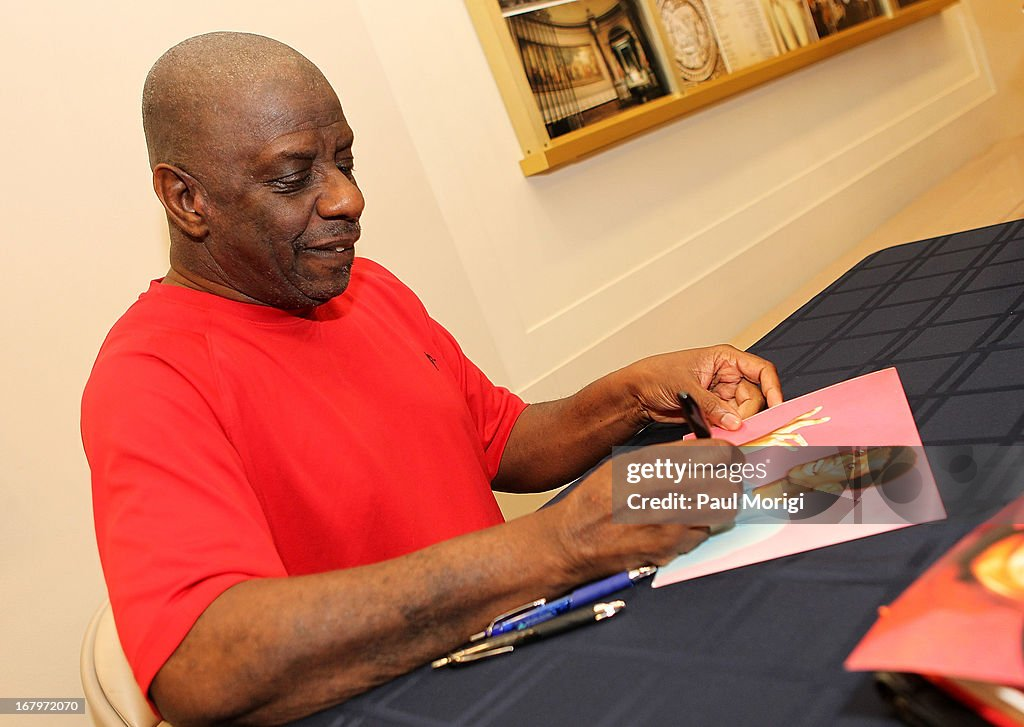Can you describe the location settings and how they contribute to the event atmosphere? The location appears to be a well-lit, indoor venue, likely a bookstore, library, or event hall. The table setup, with books or items likely related to the guest of honor displayed behind him, creates a professional yet welcoming environment. This setting is ideal for personal interactions and creates a structured but friendly atmosphere where fans can comfortably meet the guest, enhancing the overall experience of the event. What specific details in the image suggest this is not just a casual gathering? The structured setup of the table, the presence of multiple identical items ready for signing, and the focused action of the individual suggest an organized event rather than a casual gathering. Additionally, the individual appears to be methodically signing items, indicative of a formal signing session rather than a spontaneous activity. 